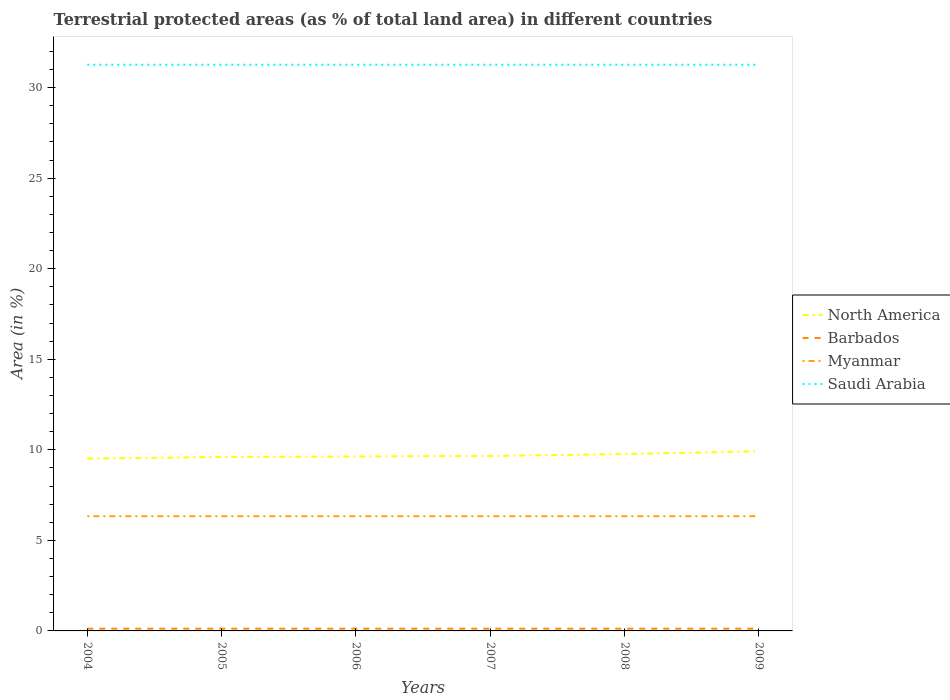Does the line corresponding to Myanmar intersect with the line corresponding to North America?
Offer a very short reply. No. Across all years, what is the maximum percentage of terrestrial protected land in Saudi Arabia?
Your answer should be very brief. 31.26. What is the difference between the highest and the second highest percentage of terrestrial protected land in Myanmar?
Your answer should be compact. 0. Is the percentage of terrestrial protected land in Barbados strictly greater than the percentage of terrestrial protected land in Myanmar over the years?
Provide a short and direct response. Yes. How many years are there in the graph?
Ensure brevity in your answer.  6. What is the difference between two consecutive major ticks on the Y-axis?
Ensure brevity in your answer.  5. Does the graph contain grids?
Give a very brief answer. No. How are the legend labels stacked?
Give a very brief answer. Vertical. What is the title of the graph?
Provide a succinct answer. Terrestrial protected areas (as % of total land area) in different countries. Does "French Polynesia" appear as one of the legend labels in the graph?
Offer a very short reply. No. What is the label or title of the Y-axis?
Keep it short and to the point. Area (in %). What is the Area (in %) in North America in 2004?
Ensure brevity in your answer.  9.52. What is the Area (in %) in Barbados in 2004?
Offer a very short reply. 0.12. What is the Area (in %) in Myanmar in 2004?
Provide a short and direct response. 6.33. What is the Area (in %) of Saudi Arabia in 2004?
Provide a succinct answer. 31.26. What is the Area (in %) of North America in 2005?
Give a very brief answer. 9.6. What is the Area (in %) of Barbados in 2005?
Give a very brief answer. 0.12. What is the Area (in %) in Myanmar in 2005?
Your response must be concise. 6.33. What is the Area (in %) in Saudi Arabia in 2005?
Make the answer very short. 31.26. What is the Area (in %) of North America in 2006?
Provide a succinct answer. 9.64. What is the Area (in %) in Barbados in 2006?
Keep it short and to the point. 0.12. What is the Area (in %) of Myanmar in 2006?
Offer a very short reply. 6.33. What is the Area (in %) of Saudi Arabia in 2006?
Ensure brevity in your answer.  31.26. What is the Area (in %) of North America in 2007?
Provide a succinct answer. 9.66. What is the Area (in %) of Barbados in 2007?
Give a very brief answer. 0.12. What is the Area (in %) in Myanmar in 2007?
Give a very brief answer. 6.33. What is the Area (in %) in Saudi Arabia in 2007?
Offer a very short reply. 31.26. What is the Area (in %) of North America in 2008?
Your response must be concise. 9.77. What is the Area (in %) in Barbados in 2008?
Offer a terse response. 0.12. What is the Area (in %) of Myanmar in 2008?
Your answer should be compact. 6.33. What is the Area (in %) of Saudi Arabia in 2008?
Provide a succinct answer. 31.26. What is the Area (in %) of North America in 2009?
Make the answer very short. 9.92. What is the Area (in %) of Barbados in 2009?
Give a very brief answer. 0.12. What is the Area (in %) in Myanmar in 2009?
Provide a short and direct response. 6.33. What is the Area (in %) in Saudi Arabia in 2009?
Make the answer very short. 31.26. Across all years, what is the maximum Area (in %) of North America?
Your answer should be very brief. 9.92. Across all years, what is the maximum Area (in %) in Barbados?
Your answer should be compact. 0.12. Across all years, what is the maximum Area (in %) in Myanmar?
Ensure brevity in your answer.  6.33. Across all years, what is the maximum Area (in %) in Saudi Arabia?
Give a very brief answer. 31.26. Across all years, what is the minimum Area (in %) in North America?
Your answer should be compact. 9.52. Across all years, what is the minimum Area (in %) in Barbados?
Your answer should be very brief. 0.12. Across all years, what is the minimum Area (in %) in Myanmar?
Provide a succinct answer. 6.33. Across all years, what is the minimum Area (in %) of Saudi Arabia?
Provide a short and direct response. 31.26. What is the total Area (in %) in North America in the graph?
Your answer should be very brief. 58.1. What is the total Area (in %) in Barbados in the graph?
Your answer should be very brief. 0.74. What is the total Area (in %) in Myanmar in the graph?
Offer a terse response. 38.01. What is the total Area (in %) of Saudi Arabia in the graph?
Your answer should be compact. 187.57. What is the difference between the Area (in %) of North America in 2004 and that in 2005?
Provide a succinct answer. -0.09. What is the difference between the Area (in %) of Barbados in 2004 and that in 2005?
Make the answer very short. 0. What is the difference between the Area (in %) in Saudi Arabia in 2004 and that in 2005?
Provide a short and direct response. 0. What is the difference between the Area (in %) in North America in 2004 and that in 2006?
Provide a short and direct response. -0.12. What is the difference between the Area (in %) of Barbados in 2004 and that in 2006?
Keep it short and to the point. 0. What is the difference between the Area (in %) in Myanmar in 2004 and that in 2006?
Offer a very short reply. 0. What is the difference between the Area (in %) of Saudi Arabia in 2004 and that in 2006?
Your answer should be very brief. 0. What is the difference between the Area (in %) of North America in 2004 and that in 2007?
Your answer should be compact. -0.14. What is the difference between the Area (in %) of Barbados in 2004 and that in 2007?
Your answer should be very brief. 0. What is the difference between the Area (in %) of North America in 2004 and that in 2008?
Make the answer very short. -0.25. What is the difference between the Area (in %) of Barbados in 2004 and that in 2008?
Give a very brief answer. 0. What is the difference between the Area (in %) in North America in 2004 and that in 2009?
Offer a terse response. -0.4. What is the difference between the Area (in %) of Barbados in 2004 and that in 2009?
Your answer should be very brief. 0. What is the difference between the Area (in %) of Saudi Arabia in 2004 and that in 2009?
Offer a terse response. 0. What is the difference between the Area (in %) in North America in 2005 and that in 2006?
Provide a succinct answer. -0.03. What is the difference between the Area (in %) of Saudi Arabia in 2005 and that in 2006?
Provide a short and direct response. 0. What is the difference between the Area (in %) of North America in 2005 and that in 2007?
Provide a succinct answer. -0.06. What is the difference between the Area (in %) in Myanmar in 2005 and that in 2007?
Ensure brevity in your answer.  0. What is the difference between the Area (in %) of North America in 2005 and that in 2008?
Make the answer very short. -0.16. What is the difference between the Area (in %) in Saudi Arabia in 2005 and that in 2008?
Give a very brief answer. 0. What is the difference between the Area (in %) in North America in 2005 and that in 2009?
Ensure brevity in your answer.  -0.32. What is the difference between the Area (in %) in Barbados in 2005 and that in 2009?
Provide a succinct answer. 0. What is the difference between the Area (in %) of Myanmar in 2005 and that in 2009?
Provide a short and direct response. 0. What is the difference between the Area (in %) of Saudi Arabia in 2005 and that in 2009?
Ensure brevity in your answer.  0. What is the difference between the Area (in %) in North America in 2006 and that in 2007?
Your answer should be very brief. -0.03. What is the difference between the Area (in %) of Barbados in 2006 and that in 2007?
Offer a terse response. 0. What is the difference between the Area (in %) of Saudi Arabia in 2006 and that in 2007?
Your answer should be very brief. 0. What is the difference between the Area (in %) in North America in 2006 and that in 2008?
Your answer should be compact. -0.13. What is the difference between the Area (in %) of Barbados in 2006 and that in 2008?
Provide a succinct answer. 0. What is the difference between the Area (in %) of Myanmar in 2006 and that in 2008?
Your response must be concise. 0. What is the difference between the Area (in %) in Saudi Arabia in 2006 and that in 2008?
Your response must be concise. 0. What is the difference between the Area (in %) of North America in 2006 and that in 2009?
Keep it short and to the point. -0.28. What is the difference between the Area (in %) in Barbados in 2006 and that in 2009?
Your answer should be very brief. 0. What is the difference between the Area (in %) of North America in 2007 and that in 2008?
Offer a very short reply. -0.11. What is the difference between the Area (in %) in North America in 2007 and that in 2009?
Give a very brief answer. -0.26. What is the difference between the Area (in %) of Barbados in 2007 and that in 2009?
Ensure brevity in your answer.  0. What is the difference between the Area (in %) of North America in 2008 and that in 2009?
Ensure brevity in your answer.  -0.15. What is the difference between the Area (in %) of Barbados in 2008 and that in 2009?
Make the answer very short. 0. What is the difference between the Area (in %) of Myanmar in 2008 and that in 2009?
Make the answer very short. 0. What is the difference between the Area (in %) in Saudi Arabia in 2008 and that in 2009?
Offer a very short reply. 0. What is the difference between the Area (in %) of North America in 2004 and the Area (in %) of Barbados in 2005?
Provide a short and direct response. 9.39. What is the difference between the Area (in %) in North America in 2004 and the Area (in %) in Myanmar in 2005?
Ensure brevity in your answer.  3.18. What is the difference between the Area (in %) in North America in 2004 and the Area (in %) in Saudi Arabia in 2005?
Your answer should be compact. -21.74. What is the difference between the Area (in %) of Barbados in 2004 and the Area (in %) of Myanmar in 2005?
Your answer should be very brief. -6.21. What is the difference between the Area (in %) of Barbados in 2004 and the Area (in %) of Saudi Arabia in 2005?
Offer a terse response. -31.14. What is the difference between the Area (in %) of Myanmar in 2004 and the Area (in %) of Saudi Arabia in 2005?
Provide a short and direct response. -24.93. What is the difference between the Area (in %) in North America in 2004 and the Area (in %) in Barbados in 2006?
Your answer should be compact. 9.39. What is the difference between the Area (in %) of North America in 2004 and the Area (in %) of Myanmar in 2006?
Your response must be concise. 3.18. What is the difference between the Area (in %) in North America in 2004 and the Area (in %) in Saudi Arabia in 2006?
Give a very brief answer. -21.74. What is the difference between the Area (in %) in Barbados in 2004 and the Area (in %) in Myanmar in 2006?
Your answer should be very brief. -6.21. What is the difference between the Area (in %) in Barbados in 2004 and the Area (in %) in Saudi Arabia in 2006?
Keep it short and to the point. -31.14. What is the difference between the Area (in %) of Myanmar in 2004 and the Area (in %) of Saudi Arabia in 2006?
Your answer should be very brief. -24.93. What is the difference between the Area (in %) in North America in 2004 and the Area (in %) in Barbados in 2007?
Ensure brevity in your answer.  9.39. What is the difference between the Area (in %) in North America in 2004 and the Area (in %) in Myanmar in 2007?
Provide a succinct answer. 3.18. What is the difference between the Area (in %) in North America in 2004 and the Area (in %) in Saudi Arabia in 2007?
Your answer should be compact. -21.74. What is the difference between the Area (in %) in Barbados in 2004 and the Area (in %) in Myanmar in 2007?
Make the answer very short. -6.21. What is the difference between the Area (in %) in Barbados in 2004 and the Area (in %) in Saudi Arabia in 2007?
Give a very brief answer. -31.14. What is the difference between the Area (in %) of Myanmar in 2004 and the Area (in %) of Saudi Arabia in 2007?
Keep it short and to the point. -24.93. What is the difference between the Area (in %) of North America in 2004 and the Area (in %) of Barbados in 2008?
Your response must be concise. 9.39. What is the difference between the Area (in %) of North America in 2004 and the Area (in %) of Myanmar in 2008?
Make the answer very short. 3.18. What is the difference between the Area (in %) in North America in 2004 and the Area (in %) in Saudi Arabia in 2008?
Make the answer very short. -21.74. What is the difference between the Area (in %) in Barbados in 2004 and the Area (in %) in Myanmar in 2008?
Give a very brief answer. -6.21. What is the difference between the Area (in %) of Barbados in 2004 and the Area (in %) of Saudi Arabia in 2008?
Your answer should be very brief. -31.14. What is the difference between the Area (in %) of Myanmar in 2004 and the Area (in %) of Saudi Arabia in 2008?
Your answer should be very brief. -24.93. What is the difference between the Area (in %) of North America in 2004 and the Area (in %) of Barbados in 2009?
Ensure brevity in your answer.  9.39. What is the difference between the Area (in %) in North America in 2004 and the Area (in %) in Myanmar in 2009?
Provide a succinct answer. 3.18. What is the difference between the Area (in %) of North America in 2004 and the Area (in %) of Saudi Arabia in 2009?
Offer a very short reply. -21.74. What is the difference between the Area (in %) in Barbados in 2004 and the Area (in %) in Myanmar in 2009?
Keep it short and to the point. -6.21. What is the difference between the Area (in %) of Barbados in 2004 and the Area (in %) of Saudi Arabia in 2009?
Make the answer very short. -31.14. What is the difference between the Area (in %) of Myanmar in 2004 and the Area (in %) of Saudi Arabia in 2009?
Offer a terse response. -24.93. What is the difference between the Area (in %) of North America in 2005 and the Area (in %) of Barbados in 2006?
Keep it short and to the point. 9.48. What is the difference between the Area (in %) in North America in 2005 and the Area (in %) in Myanmar in 2006?
Provide a short and direct response. 3.27. What is the difference between the Area (in %) of North America in 2005 and the Area (in %) of Saudi Arabia in 2006?
Your answer should be compact. -21.66. What is the difference between the Area (in %) in Barbados in 2005 and the Area (in %) in Myanmar in 2006?
Offer a very short reply. -6.21. What is the difference between the Area (in %) of Barbados in 2005 and the Area (in %) of Saudi Arabia in 2006?
Provide a succinct answer. -31.14. What is the difference between the Area (in %) of Myanmar in 2005 and the Area (in %) of Saudi Arabia in 2006?
Make the answer very short. -24.93. What is the difference between the Area (in %) of North America in 2005 and the Area (in %) of Barbados in 2007?
Offer a very short reply. 9.48. What is the difference between the Area (in %) of North America in 2005 and the Area (in %) of Myanmar in 2007?
Your answer should be compact. 3.27. What is the difference between the Area (in %) of North America in 2005 and the Area (in %) of Saudi Arabia in 2007?
Provide a succinct answer. -21.66. What is the difference between the Area (in %) in Barbados in 2005 and the Area (in %) in Myanmar in 2007?
Offer a terse response. -6.21. What is the difference between the Area (in %) of Barbados in 2005 and the Area (in %) of Saudi Arabia in 2007?
Your answer should be compact. -31.14. What is the difference between the Area (in %) of Myanmar in 2005 and the Area (in %) of Saudi Arabia in 2007?
Give a very brief answer. -24.93. What is the difference between the Area (in %) of North America in 2005 and the Area (in %) of Barbados in 2008?
Ensure brevity in your answer.  9.48. What is the difference between the Area (in %) of North America in 2005 and the Area (in %) of Myanmar in 2008?
Offer a terse response. 3.27. What is the difference between the Area (in %) in North America in 2005 and the Area (in %) in Saudi Arabia in 2008?
Offer a terse response. -21.66. What is the difference between the Area (in %) in Barbados in 2005 and the Area (in %) in Myanmar in 2008?
Ensure brevity in your answer.  -6.21. What is the difference between the Area (in %) in Barbados in 2005 and the Area (in %) in Saudi Arabia in 2008?
Give a very brief answer. -31.14. What is the difference between the Area (in %) of Myanmar in 2005 and the Area (in %) of Saudi Arabia in 2008?
Keep it short and to the point. -24.93. What is the difference between the Area (in %) in North America in 2005 and the Area (in %) in Barbados in 2009?
Make the answer very short. 9.48. What is the difference between the Area (in %) of North America in 2005 and the Area (in %) of Myanmar in 2009?
Ensure brevity in your answer.  3.27. What is the difference between the Area (in %) of North America in 2005 and the Area (in %) of Saudi Arabia in 2009?
Offer a very short reply. -21.66. What is the difference between the Area (in %) of Barbados in 2005 and the Area (in %) of Myanmar in 2009?
Provide a succinct answer. -6.21. What is the difference between the Area (in %) in Barbados in 2005 and the Area (in %) in Saudi Arabia in 2009?
Your response must be concise. -31.14. What is the difference between the Area (in %) in Myanmar in 2005 and the Area (in %) in Saudi Arabia in 2009?
Your response must be concise. -24.93. What is the difference between the Area (in %) in North America in 2006 and the Area (in %) in Barbados in 2007?
Keep it short and to the point. 9.51. What is the difference between the Area (in %) in North America in 2006 and the Area (in %) in Myanmar in 2007?
Ensure brevity in your answer.  3.3. What is the difference between the Area (in %) in North America in 2006 and the Area (in %) in Saudi Arabia in 2007?
Keep it short and to the point. -21.63. What is the difference between the Area (in %) of Barbados in 2006 and the Area (in %) of Myanmar in 2007?
Offer a very short reply. -6.21. What is the difference between the Area (in %) of Barbados in 2006 and the Area (in %) of Saudi Arabia in 2007?
Give a very brief answer. -31.14. What is the difference between the Area (in %) in Myanmar in 2006 and the Area (in %) in Saudi Arabia in 2007?
Your answer should be very brief. -24.93. What is the difference between the Area (in %) of North America in 2006 and the Area (in %) of Barbados in 2008?
Your response must be concise. 9.51. What is the difference between the Area (in %) of North America in 2006 and the Area (in %) of Myanmar in 2008?
Offer a very short reply. 3.3. What is the difference between the Area (in %) of North America in 2006 and the Area (in %) of Saudi Arabia in 2008?
Your answer should be compact. -21.63. What is the difference between the Area (in %) in Barbados in 2006 and the Area (in %) in Myanmar in 2008?
Offer a terse response. -6.21. What is the difference between the Area (in %) in Barbados in 2006 and the Area (in %) in Saudi Arabia in 2008?
Make the answer very short. -31.14. What is the difference between the Area (in %) of Myanmar in 2006 and the Area (in %) of Saudi Arabia in 2008?
Ensure brevity in your answer.  -24.93. What is the difference between the Area (in %) of North America in 2006 and the Area (in %) of Barbados in 2009?
Make the answer very short. 9.51. What is the difference between the Area (in %) in North America in 2006 and the Area (in %) in Myanmar in 2009?
Your response must be concise. 3.3. What is the difference between the Area (in %) in North America in 2006 and the Area (in %) in Saudi Arabia in 2009?
Your answer should be compact. -21.63. What is the difference between the Area (in %) of Barbados in 2006 and the Area (in %) of Myanmar in 2009?
Your answer should be compact. -6.21. What is the difference between the Area (in %) in Barbados in 2006 and the Area (in %) in Saudi Arabia in 2009?
Give a very brief answer. -31.14. What is the difference between the Area (in %) in Myanmar in 2006 and the Area (in %) in Saudi Arabia in 2009?
Offer a very short reply. -24.93. What is the difference between the Area (in %) of North America in 2007 and the Area (in %) of Barbados in 2008?
Provide a short and direct response. 9.54. What is the difference between the Area (in %) in North America in 2007 and the Area (in %) in Myanmar in 2008?
Keep it short and to the point. 3.33. What is the difference between the Area (in %) in North America in 2007 and the Area (in %) in Saudi Arabia in 2008?
Your response must be concise. -21.6. What is the difference between the Area (in %) of Barbados in 2007 and the Area (in %) of Myanmar in 2008?
Make the answer very short. -6.21. What is the difference between the Area (in %) of Barbados in 2007 and the Area (in %) of Saudi Arabia in 2008?
Offer a terse response. -31.14. What is the difference between the Area (in %) in Myanmar in 2007 and the Area (in %) in Saudi Arabia in 2008?
Keep it short and to the point. -24.93. What is the difference between the Area (in %) of North America in 2007 and the Area (in %) of Barbados in 2009?
Offer a terse response. 9.54. What is the difference between the Area (in %) in North America in 2007 and the Area (in %) in Myanmar in 2009?
Give a very brief answer. 3.33. What is the difference between the Area (in %) in North America in 2007 and the Area (in %) in Saudi Arabia in 2009?
Your answer should be compact. -21.6. What is the difference between the Area (in %) of Barbados in 2007 and the Area (in %) of Myanmar in 2009?
Give a very brief answer. -6.21. What is the difference between the Area (in %) of Barbados in 2007 and the Area (in %) of Saudi Arabia in 2009?
Give a very brief answer. -31.14. What is the difference between the Area (in %) of Myanmar in 2007 and the Area (in %) of Saudi Arabia in 2009?
Provide a succinct answer. -24.93. What is the difference between the Area (in %) of North America in 2008 and the Area (in %) of Barbados in 2009?
Provide a succinct answer. 9.64. What is the difference between the Area (in %) in North America in 2008 and the Area (in %) in Myanmar in 2009?
Ensure brevity in your answer.  3.43. What is the difference between the Area (in %) in North America in 2008 and the Area (in %) in Saudi Arabia in 2009?
Give a very brief answer. -21.5. What is the difference between the Area (in %) in Barbados in 2008 and the Area (in %) in Myanmar in 2009?
Provide a short and direct response. -6.21. What is the difference between the Area (in %) in Barbados in 2008 and the Area (in %) in Saudi Arabia in 2009?
Your answer should be very brief. -31.14. What is the difference between the Area (in %) in Myanmar in 2008 and the Area (in %) in Saudi Arabia in 2009?
Offer a very short reply. -24.93. What is the average Area (in %) of North America per year?
Your response must be concise. 9.68. What is the average Area (in %) of Barbados per year?
Provide a short and direct response. 0.12. What is the average Area (in %) of Myanmar per year?
Keep it short and to the point. 6.33. What is the average Area (in %) in Saudi Arabia per year?
Offer a very short reply. 31.26. In the year 2004, what is the difference between the Area (in %) in North America and Area (in %) in Barbados?
Give a very brief answer. 9.39. In the year 2004, what is the difference between the Area (in %) of North America and Area (in %) of Myanmar?
Your answer should be compact. 3.18. In the year 2004, what is the difference between the Area (in %) in North America and Area (in %) in Saudi Arabia?
Make the answer very short. -21.74. In the year 2004, what is the difference between the Area (in %) in Barbados and Area (in %) in Myanmar?
Offer a terse response. -6.21. In the year 2004, what is the difference between the Area (in %) of Barbados and Area (in %) of Saudi Arabia?
Keep it short and to the point. -31.14. In the year 2004, what is the difference between the Area (in %) of Myanmar and Area (in %) of Saudi Arabia?
Keep it short and to the point. -24.93. In the year 2005, what is the difference between the Area (in %) of North America and Area (in %) of Barbados?
Your response must be concise. 9.48. In the year 2005, what is the difference between the Area (in %) in North America and Area (in %) in Myanmar?
Your answer should be very brief. 3.27. In the year 2005, what is the difference between the Area (in %) in North America and Area (in %) in Saudi Arabia?
Provide a succinct answer. -21.66. In the year 2005, what is the difference between the Area (in %) of Barbados and Area (in %) of Myanmar?
Provide a short and direct response. -6.21. In the year 2005, what is the difference between the Area (in %) of Barbados and Area (in %) of Saudi Arabia?
Your response must be concise. -31.14. In the year 2005, what is the difference between the Area (in %) in Myanmar and Area (in %) in Saudi Arabia?
Provide a succinct answer. -24.93. In the year 2006, what is the difference between the Area (in %) in North America and Area (in %) in Barbados?
Provide a short and direct response. 9.51. In the year 2006, what is the difference between the Area (in %) in North America and Area (in %) in Myanmar?
Offer a terse response. 3.3. In the year 2006, what is the difference between the Area (in %) in North America and Area (in %) in Saudi Arabia?
Make the answer very short. -21.63. In the year 2006, what is the difference between the Area (in %) of Barbados and Area (in %) of Myanmar?
Your answer should be very brief. -6.21. In the year 2006, what is the difference between the Area (in %) in Barbados and Area (in %) in Saudi Arabia?
Give a very brief answer. -31.14. In the year 2006, what is the difference between the Area (in %) in Myanmar and Area (in %) in Saudi Arabia?
Your answer should be compact. -24.93. In the year 2007, what is the difference between the Area (in %) in North America and Area (in %) in Barbados?
Make the answer very short. 9.54. In the year 2007, what is the difference between the Area (in %) of North America and Area (in %) of Myanmar?
Offer a terse response. 3.33. In the year 2007, what is the difference between the Area (in %) of North America and Area (in %) of Saudi Arabia?
Provide a succinct answer. -21.6. In the year 2007, what is the difference between the Area (in %) of Barbados and Area (in %) of Myanmar?
Provide a short and direct response. -6.21. In the year 2007, what is the difference between the Area (in %) of Barbados and Area (in %) of Saudi Arabia?
Offer a terse response. -31.14. In the year 2007, what is the difference between the Area (in %) of Myanmar and Area (in %) of Saudi Arabia?
Offer a very short reply. -24.93. In the year 2008, what is the difference between the Area (in %) of North America and Area (in %) of Barbados?
Offer a terse response. 9.64. In the year 2008, what is the difference between the Area (in %) in North America and Area (in %) in Myanmar?
Make the answer very short. 3.43. In the year 2008, what is the difference between the Area (in %) in North America and Area (in %) in Saudi Arabia?
Your answer should be very brief. -21.5. In the year 2008, what is the difference between the Area (in %) of Barbados and Area (in %) of Myanmar?
Offer a terse response. -6.21. In the year 2008, what is the difference between the Area (in %) of Barbados and Area (in %) of Saudi Arabia?
Your answer should be very brief. -31.14. In the year 2008, what is the difference between the Area (in %) of Myanmar and Area (in %) of Saudi Arabia?
Provide a succinct answer. -24.93. In the year 2009, what is the difference between the Area (in %) of North America and Area (in %) of Barbados?
Your answer should be very brief. 9.79. In the year 2009, what is the difference between the Area (in %) of North America and Area (in %) of Myanmar?
Give a very brief answer. 3.58. In the year 2009, what is the difference between the Area (in %) in North America and Area (in %) in Saudi Arabia?
Offer a terse response. -21.34. In the year 2009, what is the difference between the Area (in %) in Barbados and Area (in %) in Myanmar?
Provide a short and direct response. -6.21. In the year 2009, what is the difference between the Area (in %) of Barbados and Area (in %) of Saudi Arabia?
Provide a short and direct response. -31.14. In the year 2009, what is the difference between the Area (in %) of Myanmar and Area (in %) of Saudi Arabia?
Offer a terse response. -24.93. What is the ratio of the Area (in %) in North America in 2004 to that in 2005?
Give a very brief answer. 0.99. What is the ratio of the Area (in %) of North America in 2004 to that in 2006?
Your response must be concise. 0.99. What is the ratio of the Area (in %) of Myanmar in 2004 to that in 2006?
Make the answer very short. 1. What is the ratio of the Area (in %) of North America in 2004 to that in 2007?
Your response must be concise. 0.99. What is the ratio of the Area (in %) of Barbados in 2004 to that in 2007?
Provide a short and direct response. 1. What is the ratio of the Area (in %) of Myanmar in 2004 to that in 2007?
Your answer should be very brief. 1. What is the ratio of the Area (in %) in Saudi Arabia in 2004 to that in 2007?
Provide a succinct answer. 1. What is the ratio of the Area (in %) in North America in 2004 to that in 2008?
Your answer should be compact. 0.97. What is the ratio of the Area (in %) of Saudi Arabia in 2004 to that in 2008?
Give a very brief answer. 1. What is the ratio of the Area (in %) in North America in 2004 to that in 2009?
Offer a terse response. 0.96. What is the ratio of the Area (in %) of Saudi Arabia in 2004 to that in 2009?
Ensure brevity in your answer.  1. What is the ratio of the Area (in %) of North America in 2005 to that in 2006?
Give a very brief answer. 1. What is the ratio of the Area (in %) of Saudi Arabia in 2005 to that in 2006?
Your response must be concise. 1. What is the ratio of the Area (in %) of Myanmar in 2005 to that in 2007?
Provide a short and direct response. 1. What is the ratio of the Area (in %) in North America in 2005 to that in 2008?
Keep it short and to the point. 0.98. What is the ratio of the Area (in %) in Barbados in 2005 to that in 2008?
Give a very brief answer. 1. What is the ratio of the Area (in %) of Saudi Arabia in 2005 to that in 2008?
Your response must be concise. 1. What is the ratio of the Area (in %) of North America in 2005 to that in 2009?
Make the answer very short. 0.97. What is the ratio of the Area (in %) in Barbados in 2005 to that in 2009?
Offer a terse response. 1. What is the ratio of the Area (in %) in Myanmar in 2005 to that in 2009?
Ensure brevity in your answer.  1. What is the ratio of the Area (in %) in Saudi Arabia in 2005 to that in 2009?
Provide a short and direct response. 1. What is the ratio of the Area (in %) in North America in 2006 to that in 2007?
Keep it short and to the point. 1. What is the ratio of the Area (in %) in North America in 2006 to that in 2008?
Make the answer very short. 0.99. What is the ratio of the Area (in %) of Barbados in 2006 to that in 2008?
Offer a very short reply. 1. What is the ratio of the Area (in %) of Saudi Arabia in 2006 to that in 2008?
Give a very brief answer. 1. What is the ratio of the Area (in %) in North America in 2006 to that in 2009?
Your response must be concise. 0.97. What is the ratio of the Area (in %) of Barbados in 2006 to that in 2009?
Provide a succinct answer. 1. What is the ratio of the Area (in %) in Myanmar in 2006 to that in 2009?
Keep it short and to the point. 1. What is the ratio of the Area (in %) of North America in 2007 to that in 2008?
Give a very brief answer. 0.99. What is the ratio of the Area (in %) of Barbados in 2007 to that in 2008?
Make the answer very short. 1. What is the ratio of the Area (in %) of Myanmar in 2007 to that in 2008?
Provide a succinct answer. 1. What is the ratio of the Area (in %) of Saudi Arabia in 2007 to that in 2008?
Offer a terse response. 1. What is the ratio of the Area (in %) in North America in 2007 to that in 2009?
Provide a succinct answer. 0.97. What is the ratio of the Area (in %) in Barbados in 2007 to that in 2009?
Your answer should be very brief. 1. What is the ratio of the Area (in %) of Saudi Arabia in 2007 to that in 2009?
Make the answer very short. 1. What is the ratio of the Area (in %) in North America in 2008 to that in 2009?
Make the answer very short. 0.98. What is the ratio of the Area (in %) of Myanmar in 2008 to that in 2009?
Your response must be concise. 1. What is the difference between the highest and the second highest Area (in %) of North America?
Provide a succinct answer. 0.15. What is the difference between the highest and the second highest Area (in %) of Myanmar?
Keep it short and to the point. 0. What is the difference between the highest and the second highest Area (in %) in Saudi Arabia?
Provide a succinct answer. 0. What is the difference between the highest and the lowest Area (in %) of North America?
Give a very brief answer. 0.4. What is the difference between the highest and the lowest Area (in %) in Barbados?
Offer a terse response. 0. What is the difference between the highest and the lowest Area (in %) of Saudi Arabia?
Make the answer very short. 0. 